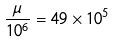<formula> <loc_0><loc_0><loc_500><loc_500>\frac { \mu } { 1 0 ^ { 6 } } = 4 9 \times 1 0 ^ { 5 }</formula> 